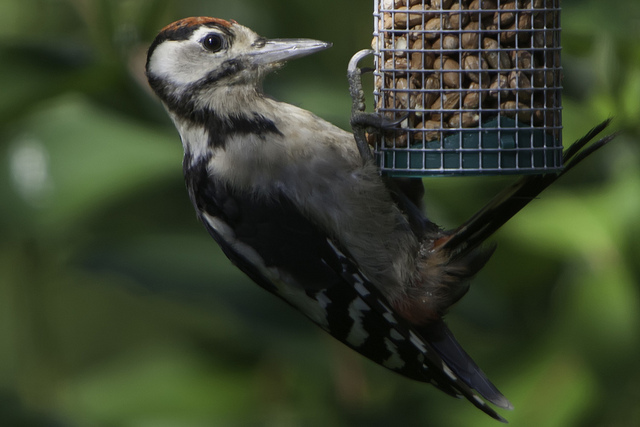<image>What type of bird is this? I don't know what type of bird it is. It could possibly be a woodpecker or a robin. What species is the bird? I am not sure about the species of the bird. It could be a woodpecker, parrot, finch, sparrow, or robin. What type of bird is this? I don't know what type of bird it is. It can be seen as a woodpecker or a robin, but I am not sure. What species is the bird? I am not sure about the species of the bird. It can be 'woodpecker', 'parrott', 'finch', 'sparrow', or 'robin'. 